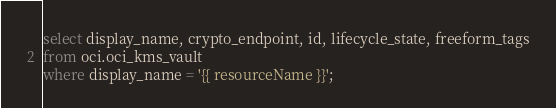Convert code to text. <code><loc_0><loc_0><loc_500><loc_500><_SQL_>select display_name, crypto_endpoint, id, lifecycle_state, freeform_tags
from oci.oci_kms_vault
where display_name = '{{ resourceName }}';</code> 